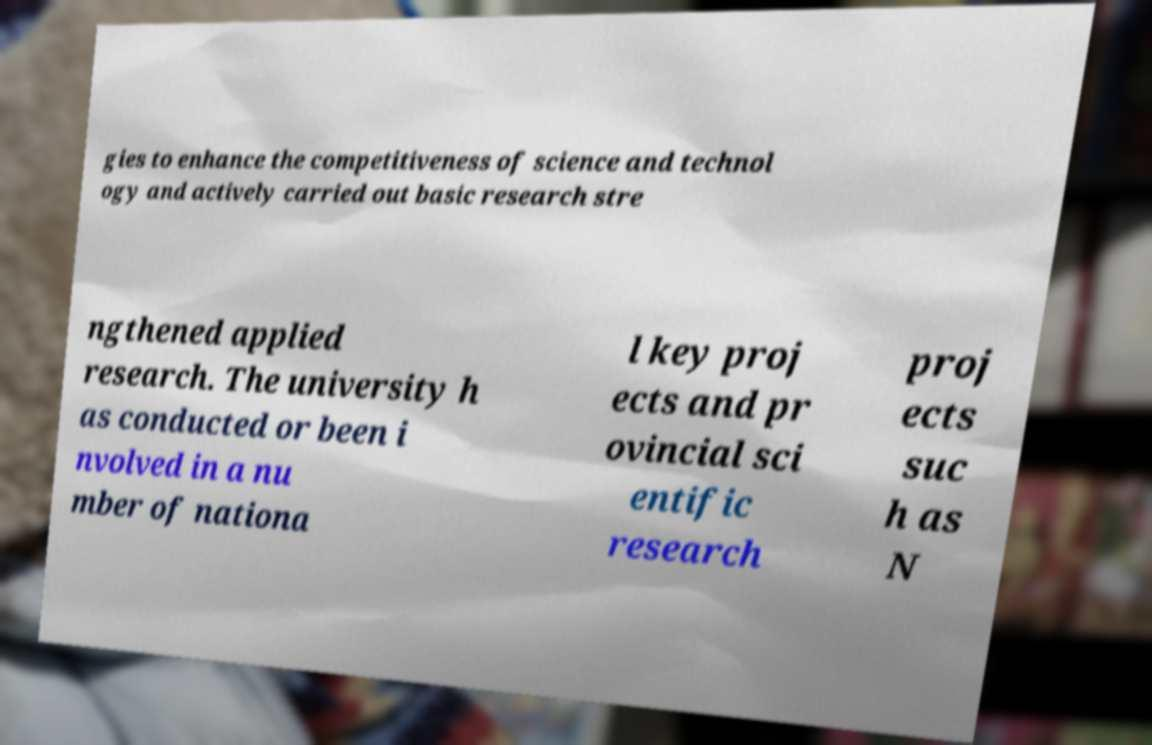Please read and relay the text visible in this image. What does it say? gies to enhance the competitiveness of science and technol ogy and actively carried out basic research stre ngthened applied research. The university h as conducted or been i nvolved in a nu mber of nationa l key proj ects and pr ovincial sci entific research proj ects suc h as N 